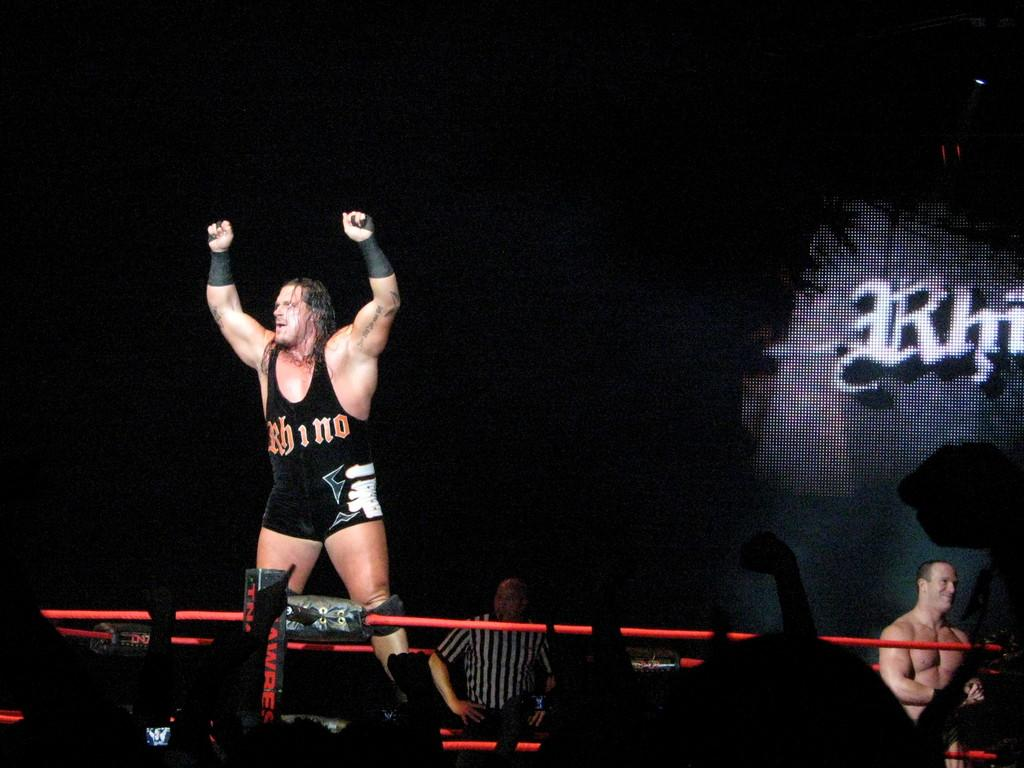<image>
Describe the image concisely. wrestler Rhino holding his arms up on the platform behind the ropes 